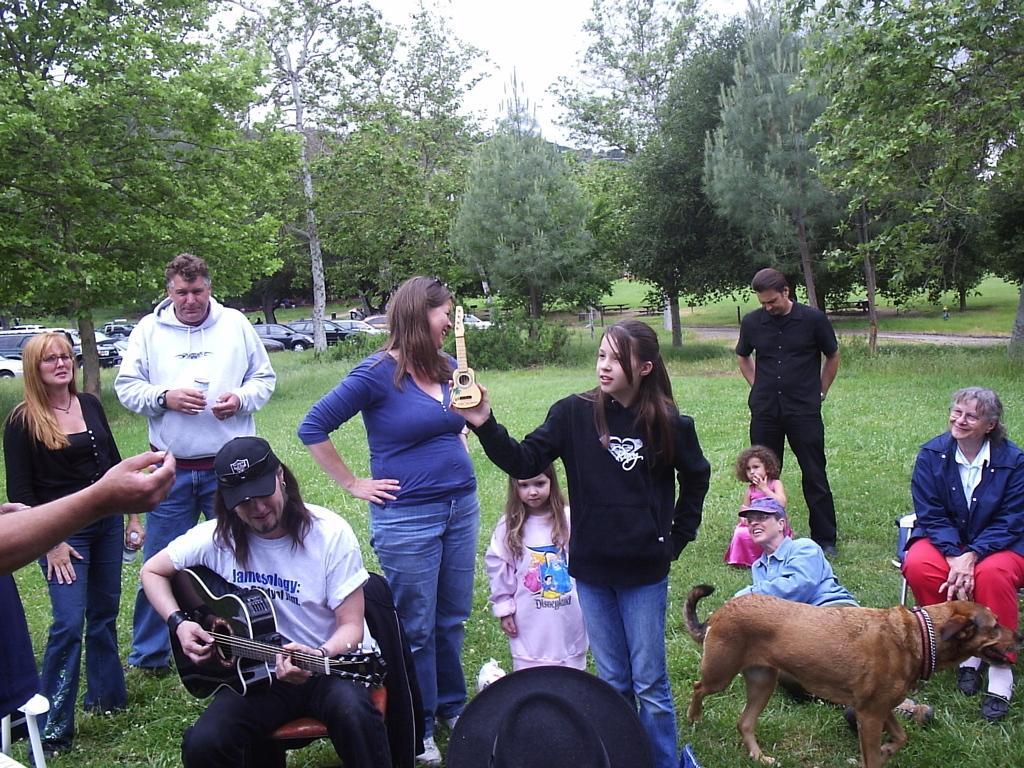Please provide a concise description of this image. Here a man is playing guitar and there are few people around him and a dog. In the background there are trees,vehicles and sky. 